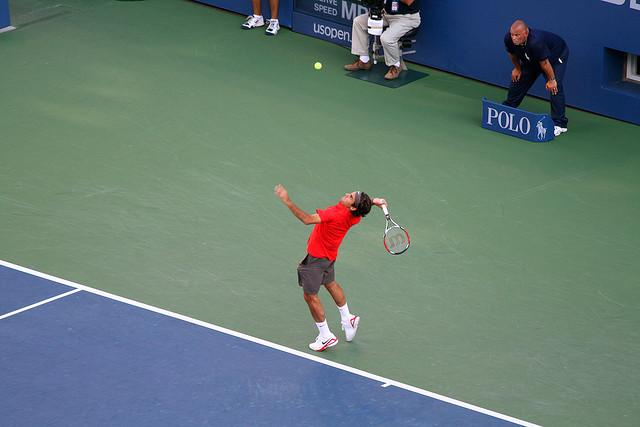What part of tennis is happening?

Choices:
A) serve
B) side spin
C) block
D) backhand serve 